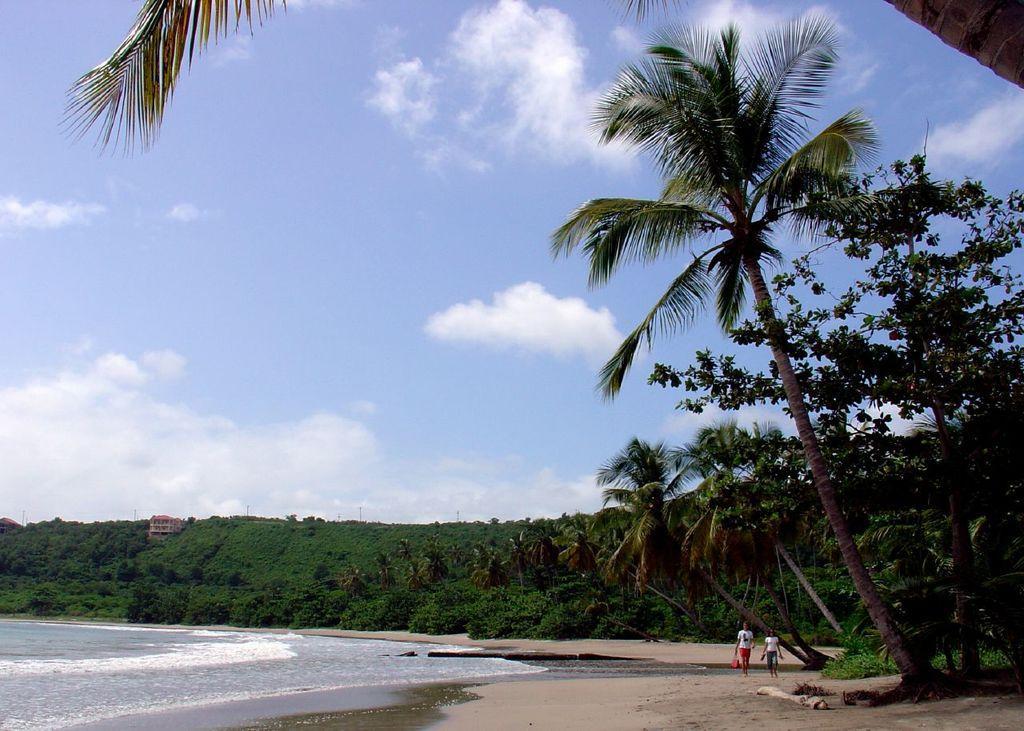Could you give a brief overview of what you see in this image? In this image I can see two persons walking and I can see the water, few trees in green color, buildings and the sky is in blue and white color. 